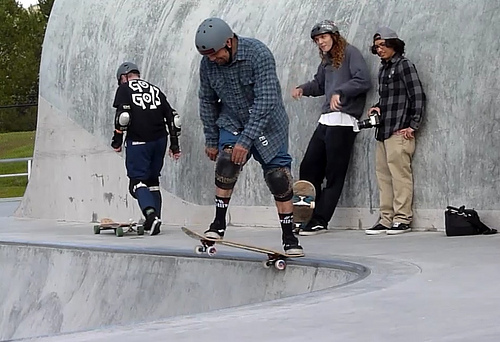What activity is taking place in the image? The image depicts a group of individuals at a skate park, engaging in skateboarding. One person is actively skateboarding on the curved ramp, while others are watching and waiting their turn. 